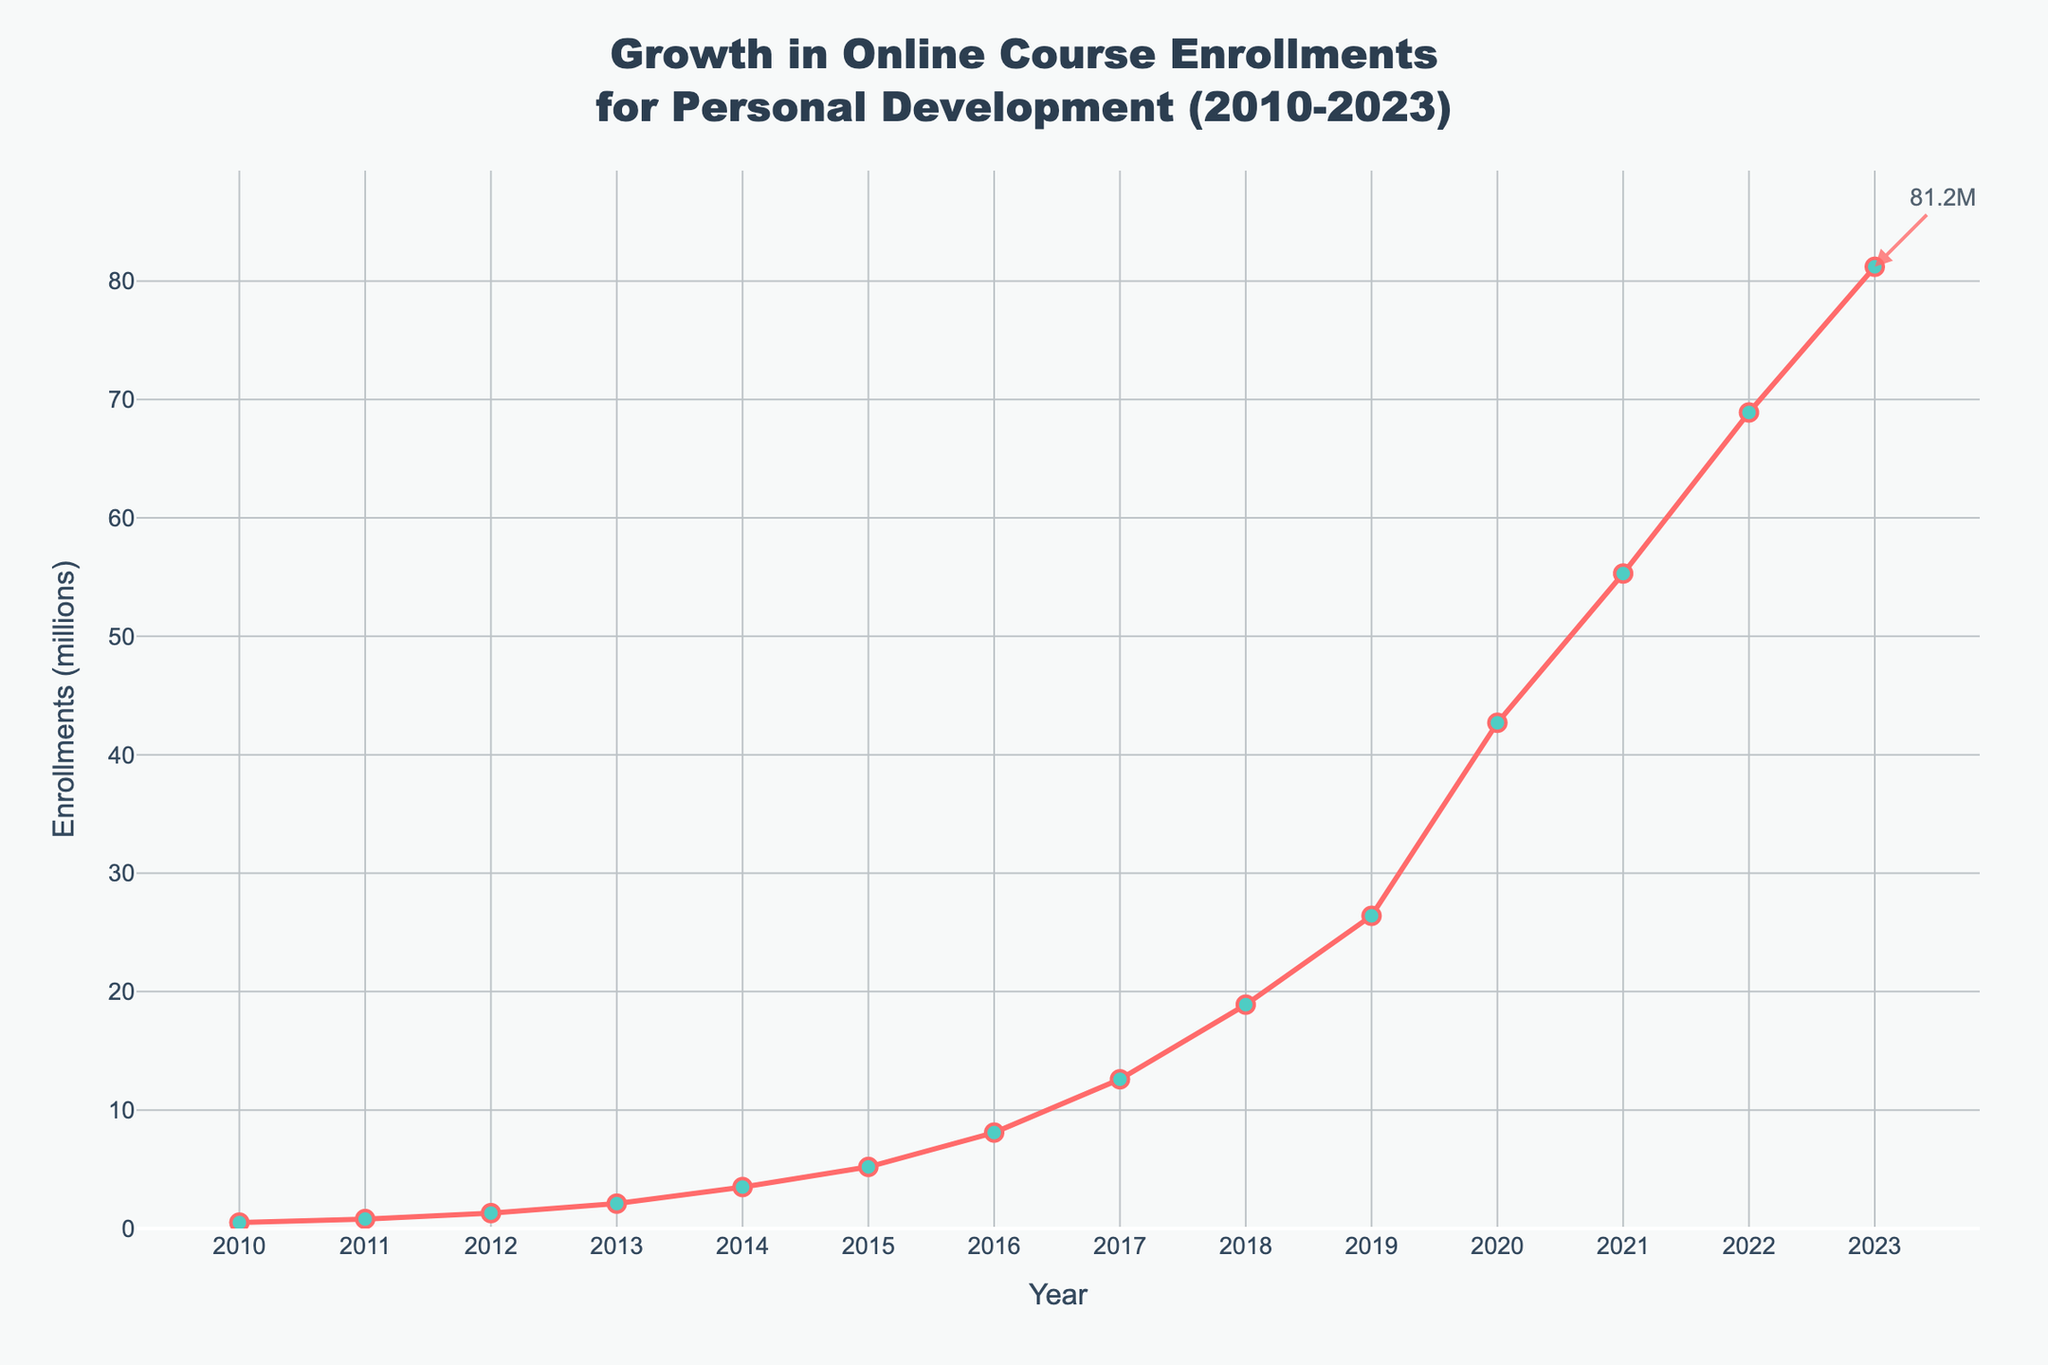What is the overall trend in the number of enrollments from 2010 to 2023? Observing the line representing enrollments from 2010 to 2023, we see that it consistently increases with each passing year, indicating a significant upward trend.
Answer: Increasing In which year did enrollments first exceed 10 million? Checking the values along the y-axis, we observe that enrollments exceed 10 million in 2017 for the first time.
Answer: 2017 What is the increase in enrollments from 2015 to 2023? The enrollments in 2015 were 5.2 million, and in 2023 they were 81.2 million. The increase is 81.2 - 5.2 = 76 million.
Answer: 76 million During which period did the steepest increase in enrollments occur? By visually inspecting the steepness of the line, the most significant increase occurs between 2019 and 2020.
Answer: 2019 to 2020 What is the average annual growth in enrollments from 2010 to 2023? To find the average annual growth: (Enrollments in 2023 - Enrollments in 2010) / (2023 - 2010). This works out to (81.2 - 0.5) / 13 = 80.7 / 13 ≈ 6.21 million per year.
Answer: 6.21 million per year How does the enrollment in 2020 compare to 2019 in terms of percentage increase? Enrollments in 2020 = 42.7 million and in 2019 = 26.4 million. Percentage increase = ((42.7 - 26.4) / 26.4) * 100 ≈ 61.74%.
Answer: ≈ 61.74% What is the total number of enrollments from 2010 to 2023? Sum of enrollments: 0.5 + 0.8 + 1.3 + 2.1 + 3.5 + 5.2 + 8.1 + 12.6 + 18.9 + 26.4 + 42.7 + 55.3 + 68.9 + 81.2 = 328.5 million.
Answer: 328.5 million Which year shows a noticeable spike in enrollment growth? Visual inspection shows a noticeable spike from 2019 to 2020.
Answer: 2020 By how much did enrollments increase from 2012 to 2013? Enrollments in 2012 were 1.3 million, and in 2013 they were 2.1 million. The increase is 2.1 - 1.3 = 0.8 million.
Answer: 0.8 million What is the median value of enrollments from 2010 to 2023? The median value is the middle number when the enrollments are arranged in ascending order. With 14 data points, the median is the average of the 7th and 8th values: (8.1 + 12.6) / 2 = 10.35 million.
Answer: 10.35 million 